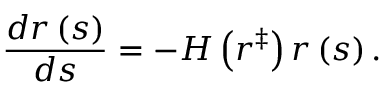<formula> <loc_0><loc_0><loc_500><loc_500>\frac { d r \left ( s \right ) } { d s } = - H \left ( r ^ { \ddag } \right ) r \left ( s \right ) .</formula> 